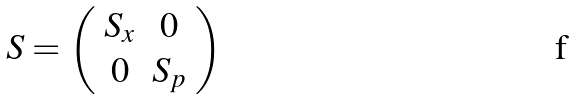Convert formula to latex. <formula><loc_0><loc_0><loc_500><loc_500>S = \left ( \begin{array} { c c } S _ { x } & 0 \\ 0 & S _ { p } \end{array} \right )</formula> 